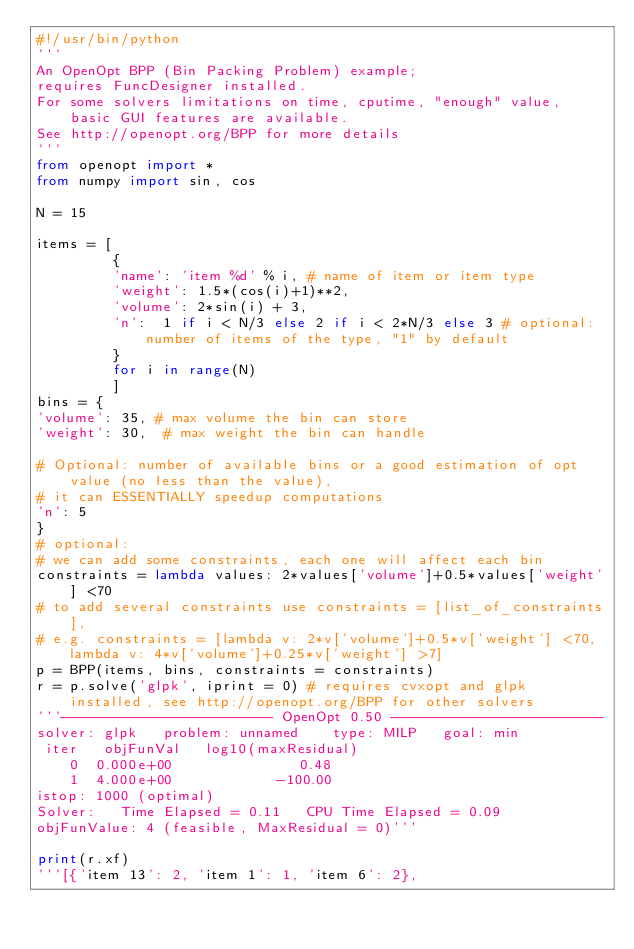<code> <loc_0><loc_0><loc_500><loc_500><_Python_>#!/usr/bin/python
'''
An OpenOpt BPP (Bin Packing Problem) example;
requires FuncDesigner installed.
For some solvers limitations on time, cputime, "enough" value, basic GUI features are available.
See http://openopt.org/BPP for more details
'''
from openopt import *
from numpy import sin, cos

N = 15

items = [
         {
         'name': 'item %d' % i, # name of item or item type
         'weight': 1.5*(cos(i)+1)**2, 
         'volume': 2*sin(i) + 3, 
         'n':  1 if i < N/3 else 2 if i < 2*N/3 else 3 # optional: number of items of the type, "1" by default
         } 
         for i in range(N)
         ]
bins = {
'volume': 35, # max volume the bin can store
'weight': 30,  # max weight the bin can handle

# Optional: number of available bins or a good estimation of opt value (no less than the value), 
# it can ESSENTIALLY speedup computations
'n': 5
}
# optional:
# we can add some constraints, each one will affect each bin
constraints = lambda values: 2*values['volume']+0.5*values['weight'] <70
# to add several constraints use constraints = [list_of_constraints],
# e.g. constraints = [lambda v: 2*v['volume']+0.5*v['weight'] <70, lambda v: 4*v['volume']+0.25*v['weight'] >7]
p = BPP(items, bins, constraints = constraints) 
r = p.solve('glpk', iprint = 0) # requires cvxopt and glpk installed, see http://openopt.org/BPP for other solvers
'''------------------------- OpenOpt 0.50 -------------------------
solver: glpk   problem: unnamed    type: MILP   goal: min
 iter   objFunVal   log10(maxResidual)   
    0  0.000e+00               0.48 
    1  4.000e+00            -100.00 
istop: 1000 (optimal)
Solver:   Time Elapsed = 0.11 	CPU Time Elapsed = 0.09
objFunValue: 4 (feasible, MaxResidual = 0)'''

print(r.xf) 
'''[{'item 13': 2, 'item 1': 1, 'item 6': 2}, </code> 